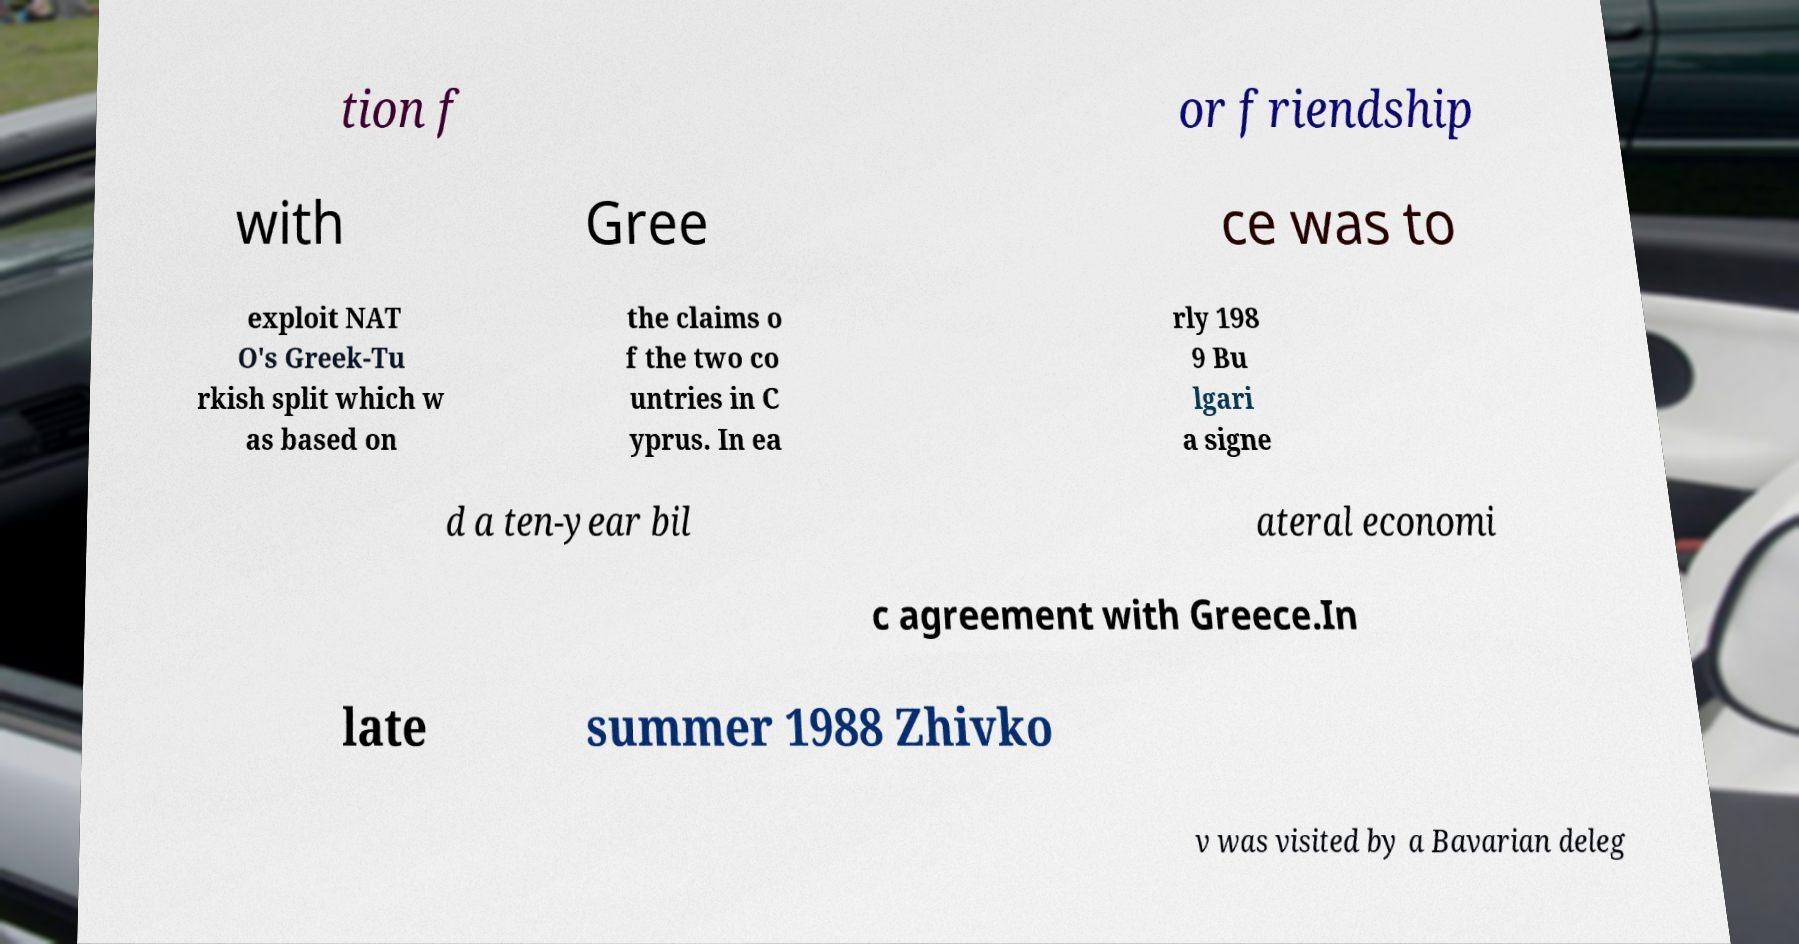Can you read and provide the text displayed in the image?This photo seems to have some interesting text. Can you extract and type it out for me? tion f or friendship with Gree ce was to exploit NAT O's Greek-Tu rkish split which w as based on the claims o f the two co untries in C yprus. In ea rly 198 9 Bu lgari a signe d a ten-year bil ateral economi c agreement with Greece.In late summer 1988 Zhivko v was visited by a Bavarian deleg 